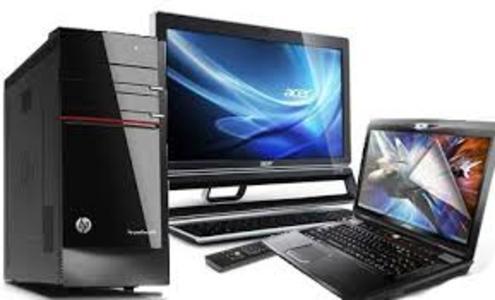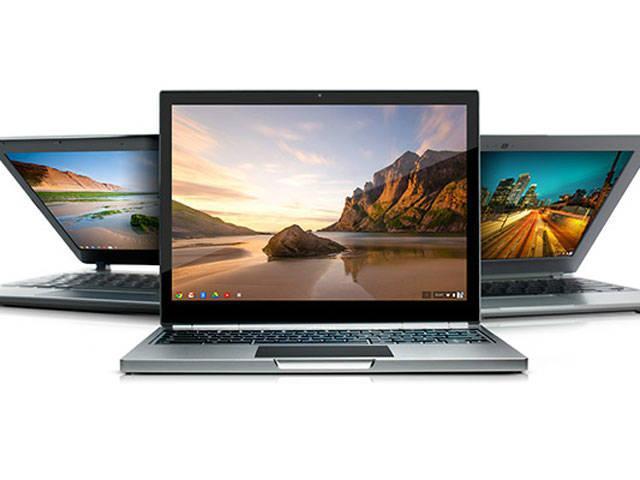The first image is the image on the left, the second image is the image on the right. Assess this claim about the two images: "The right image contains three or more computers.". Correct or not? Answer yes or no. Yes. 